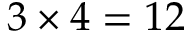<formula> <loc_0><loc_0><loc_500><loc_500>3 \times 4 = 1 2</formula> 